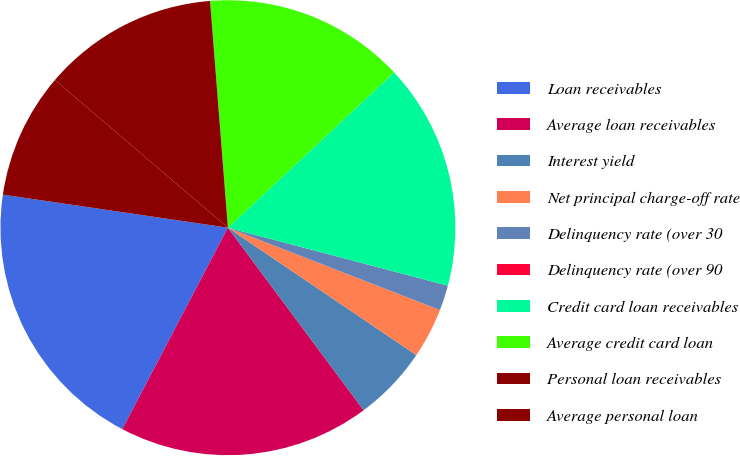Convert chart to OTSL. <chart><loc_0><loc_0><loc_500><loc_500><pie_chart><fcel>Loan receivables<fcel>Average loan receivables<fcel>Interest yield<fcel>Net principal charge-off rate<fcel>Delinquency rate (over 30<fcel>Delinquency rate (over 90<fcel>Credit card loan receivables<fcel>Average credit card loan<fcel>Personal loan receivables<fcel>Average personal loan<nl><fcel>19.64%<fcel>17.86%<fcel>5.36%<fcel>3.57%<fcel>1.79%<fcel>0.0%<fcel>16.07%<fcel>14.29%<fcel>12.5%<fcel>8.93%<nl></chart> 